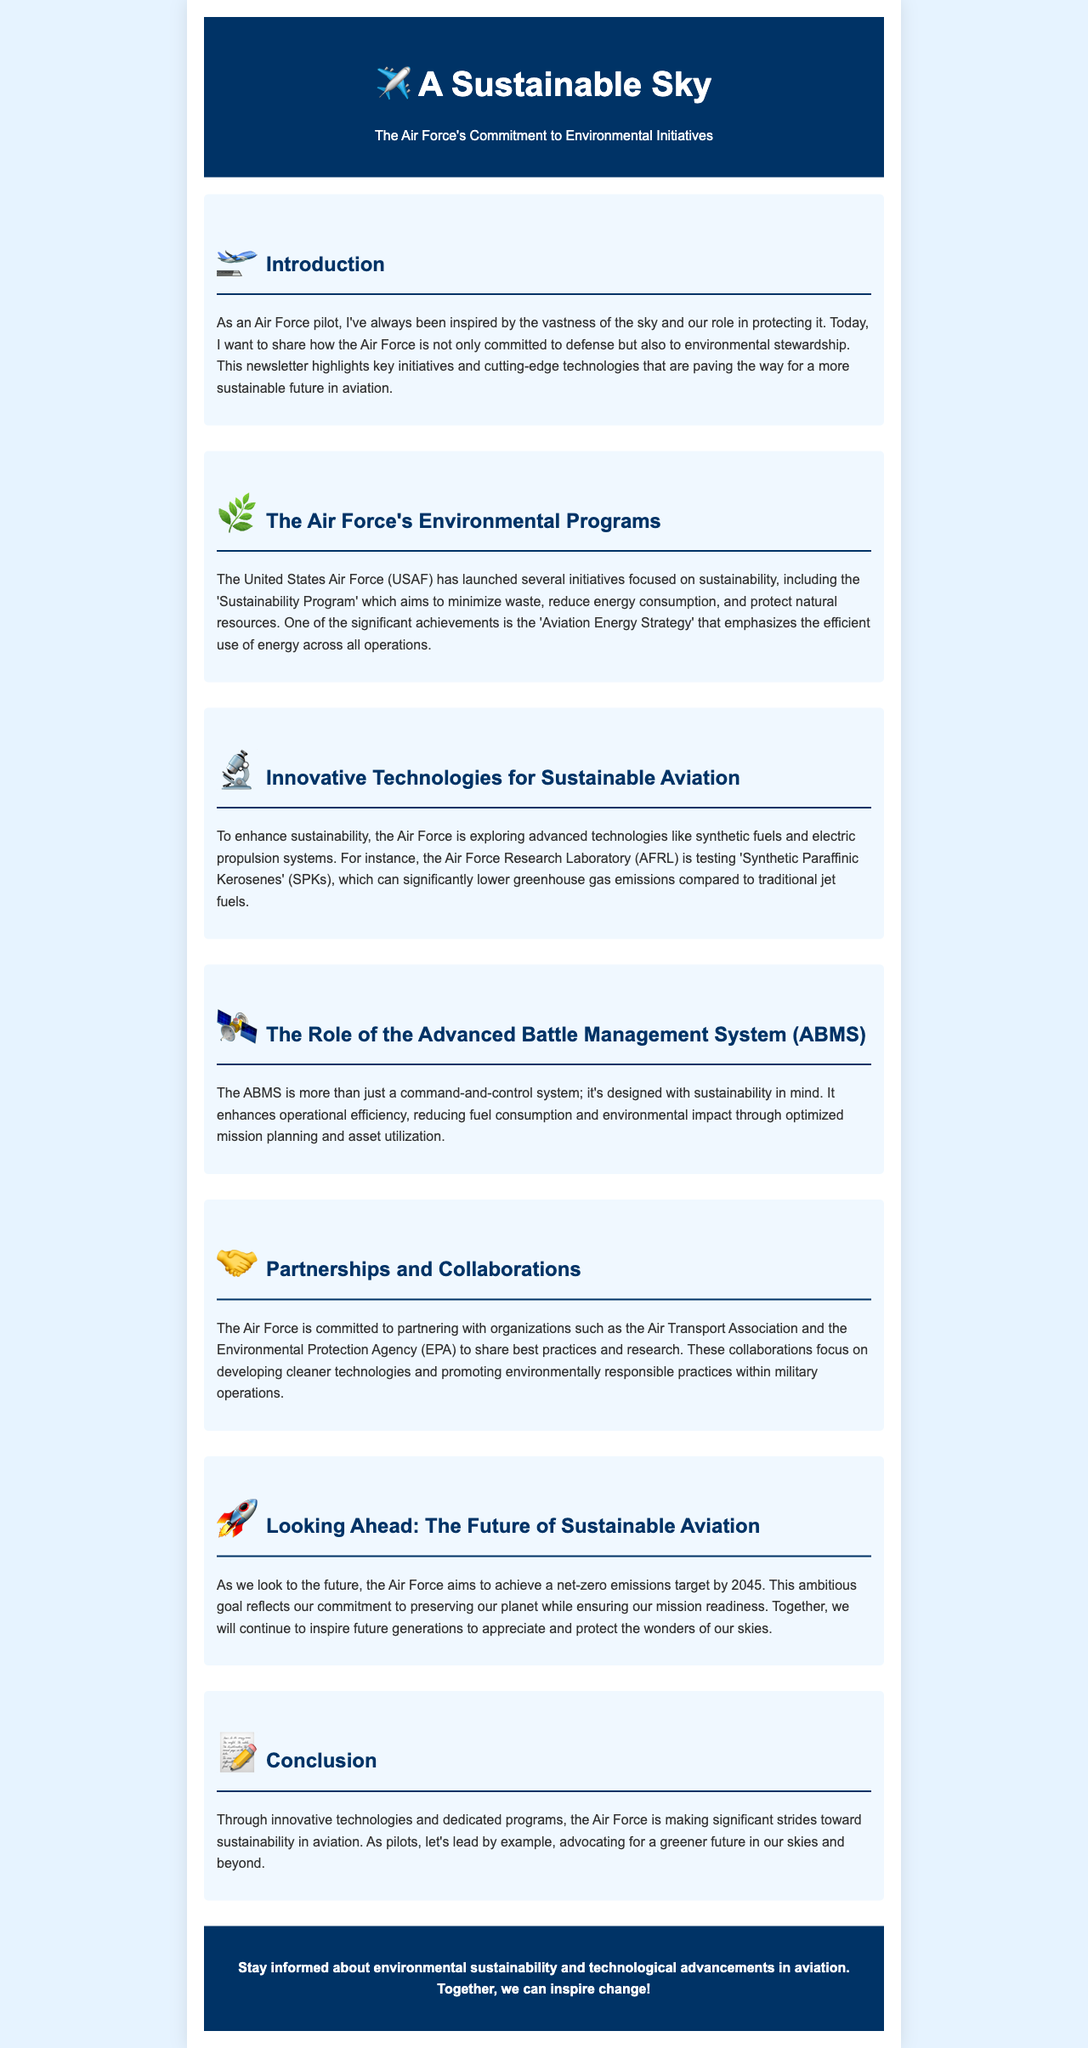What is the title of the newsletter? The title of the newsletter is mentioned prominently at the top of the document.
Answer: A Sustainable Sky: The Air Force's Commitment to Environmental Initiatives What does the 'Aviation Energy Strategy' focus on? The 'Aviation Energy Strategy' is highlighted as a significant achievement within the sustainability initiatives of the Air Force.
Answer: Efficient use of energy What technology is the Air Force testing to lower greenhouse gas emissions? The newsletter states that the Air Force is exploring specific technologies to improve environmental outcomes.
Answer: Synthetic Paraffinic Kerosenes What is the Air Force's emissions target year? The document's future goals clearly specify the target year for net-zero emissions.
Answer: 2045 Which organization collaborates with the Air Force for sustainability practices? The newsletter mentions specific organizations partnering with the Air Force to promote environmental responsibility.
Answer: Environmental Protection Agency (EPA) How does the Advanced Battle Management System (ABMS) contribute to sustainability? The document explains the purpose of ABMS in relation to fuel consumption and environmental impact.
Answer: Reducing fuel consumption What main themes are highlighted in the introduction section? The introduction emphasizes key ideas related to the Air Force's dual role.
Answer: Defense and environmental stewardship What is the primary goal of the Air Force’s sustainability initiatives? The newsletter outlines the overarching aim of these initiatives in its content.
Answer: Environmental stewardship 